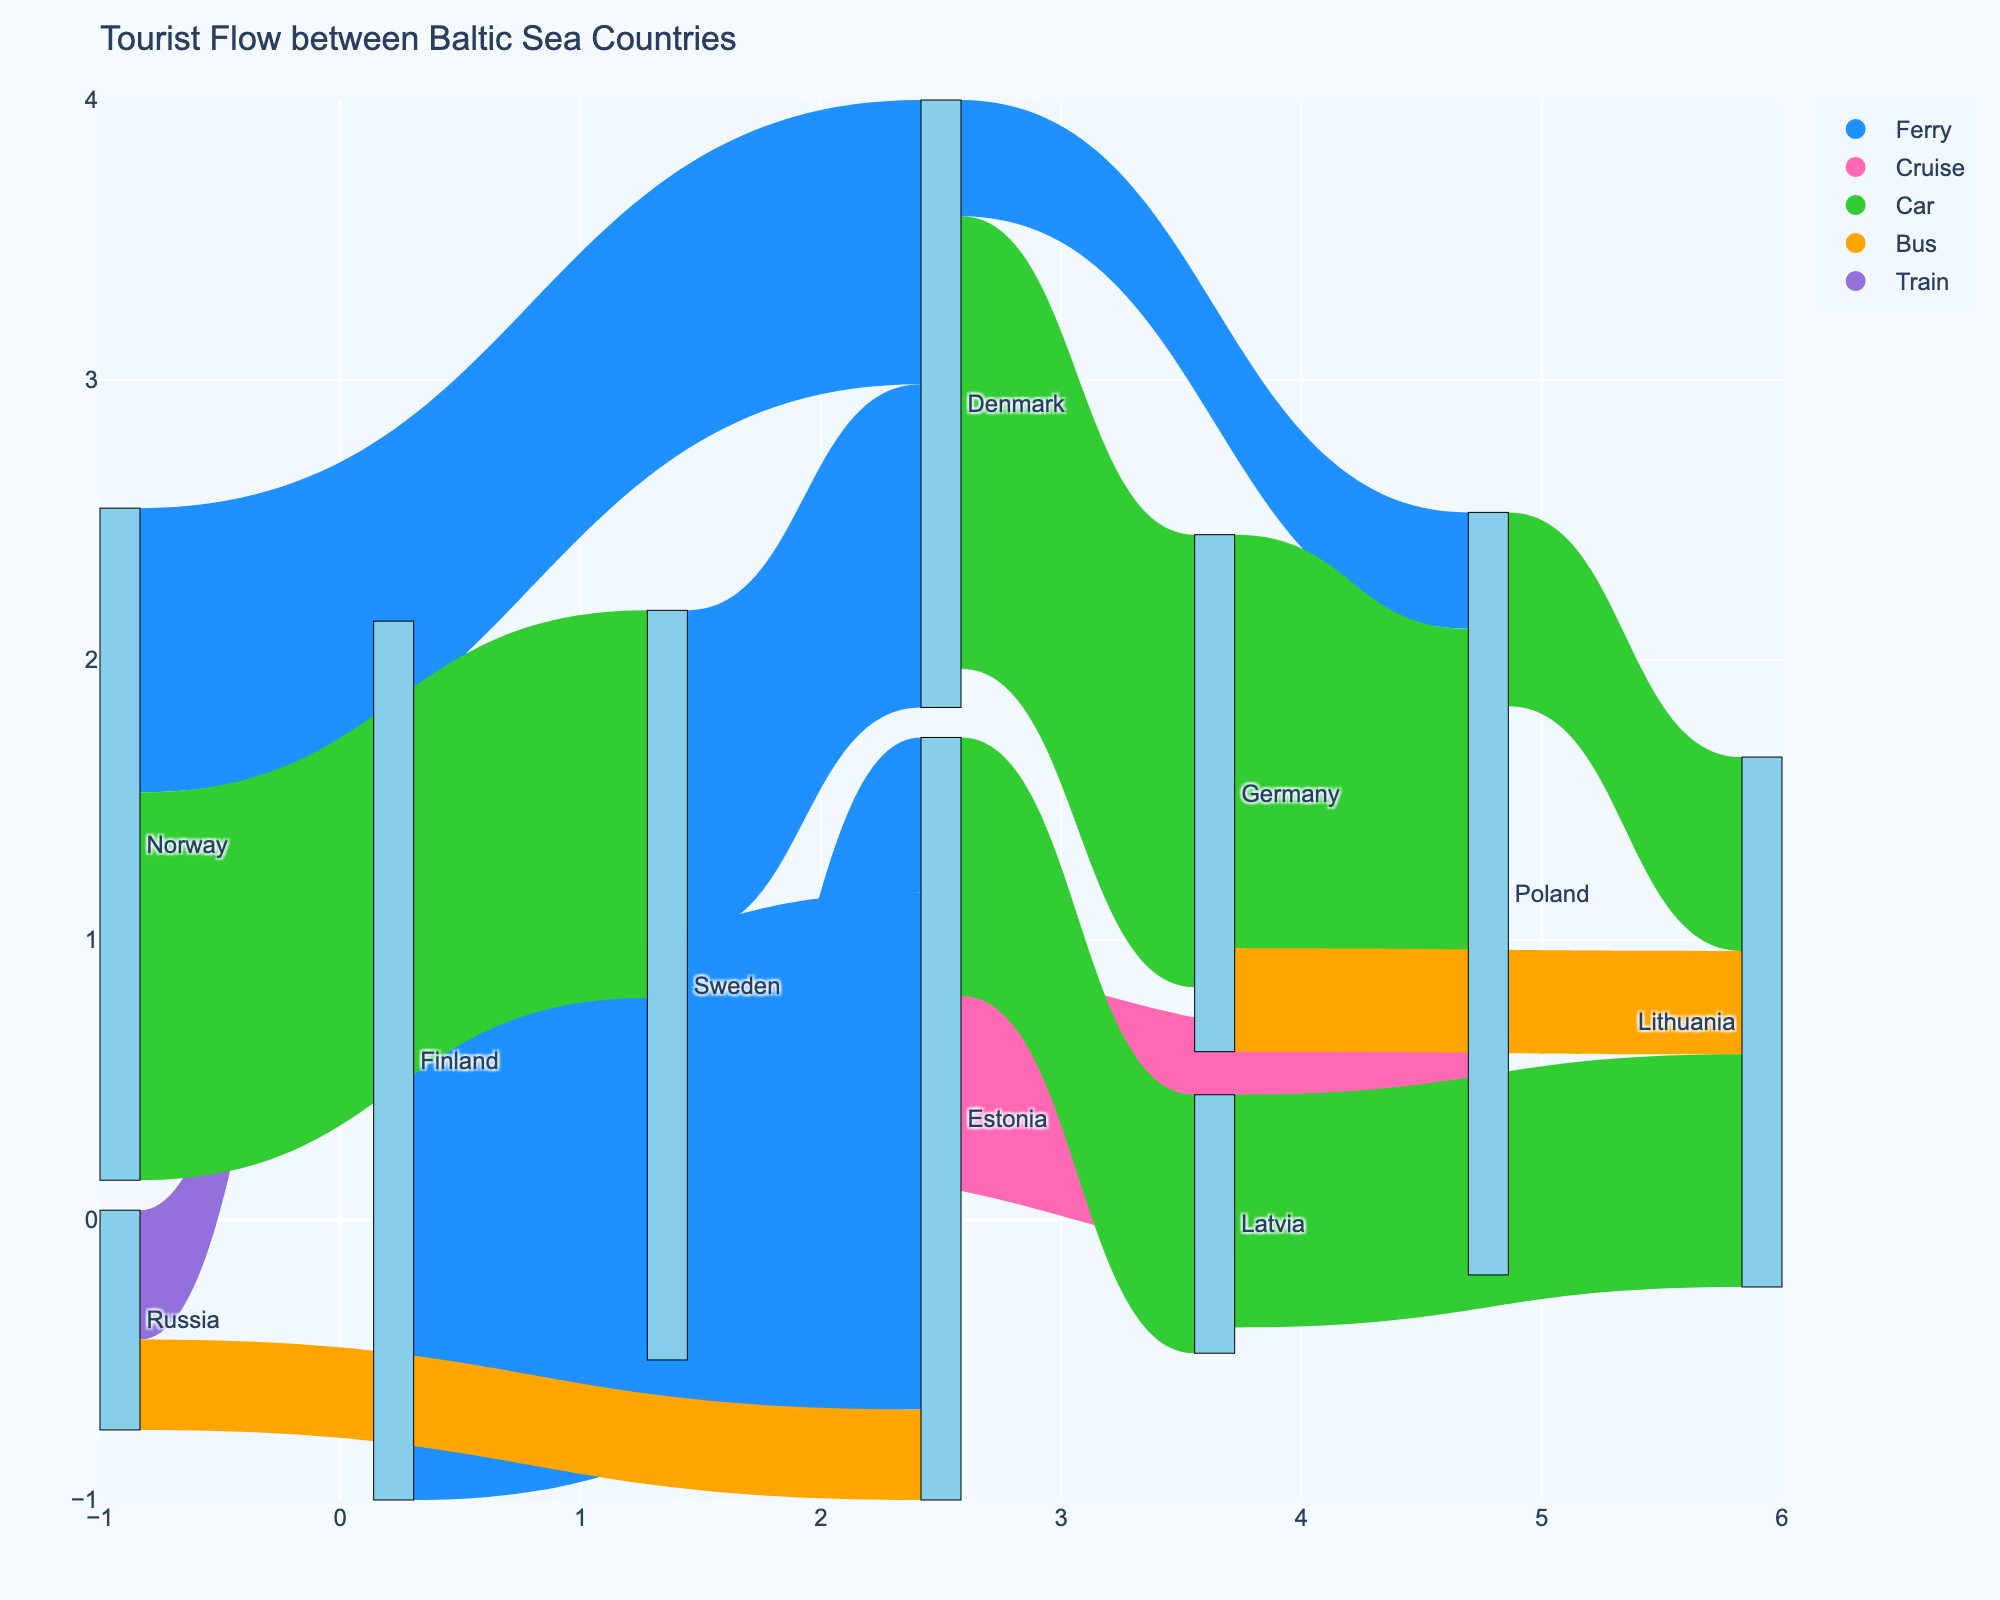How many tourists traveled from Norway to Denmark by ferry? Look at the link between Norway and Denmark, and check the value associated with the 'Ferry' mode indicated by the blue color.
Answer: 220,000 Which country had the highest number of tourists traveling to another country by car? Check all the links where the travel mode is 'Car' (indicated by green color) and compare the values. The link between Denmark and Germany shows the highest value.
Answer: Denmark What is the total number of tourists traveling from Sweden to other countries? Sum the values of all the links originating from Sweden: 250,000 (to Denmark), 180,000 (to Poland), and 120,000 (to Estonia), which equals 550,000.
Answer: 550,000 Which transportation mode is used for the tourist flow from Russia to Finland? Identify the link between Russia and Finland and look for the mode associated with that link, indicated by the color. The color for this link is purple, which corresponds to trains.
Answer: Train How many tourists in total traveled to Poland? Sum all the values of the links where Poland is the target: 180,000 (from Sweden), 90,000 (from Denmark), and 320,000 (from Germany), which equals 590,000.
Answer: 590,000 Compare the tourist flow from Finland to Sweden and Sweden to Finland. Which direction had more tourists? Compare the values for the links in both directions: 280,000 (Finland to Sweden) and 0 (Sweden to Finland, as it's not included in the data). Hence, Finland to Sweden had more tourists.
Answer: Finland to Sweden Which mode of transportation has the least number of tourists traveling through it? Check the values for all the transportation modes and identify the smallest value. The 'Bus' mode from Germany to Lithuania (80,000) and Russia to Estonia (70,000) shows the lowest numbers. The smallest among them is 70,000 for 'Bus'.
Answer: Bus Which link has the highest number of tourists using a ferry? Compare the values for 'Ferry' links and identify the highest one. The link from Finland to Estonia has the highest value of 400,000.
Answer: Finland to Estonia What is the total number of tourists traveling by bus between all countries? Sum the values of all the links where the mode is 'Bus': 80,000 (Germany to Lithuania) and 70,000 (Russia to Estonia), which equals 150,000.
Answer: 150,000 What is the sum of tourists traveling by car between all countries? Sum the values of all the links where the mode is 'Car': 350,000 (Denmark to Germany), 320,000 (Germany to Poland), 200,000 (Estonia to Latvia), 180,000 (Latvia to Lithuania), and 300,000 (Norway to Sweden), totaling 1,350,000.
Answer: 1,350,000 